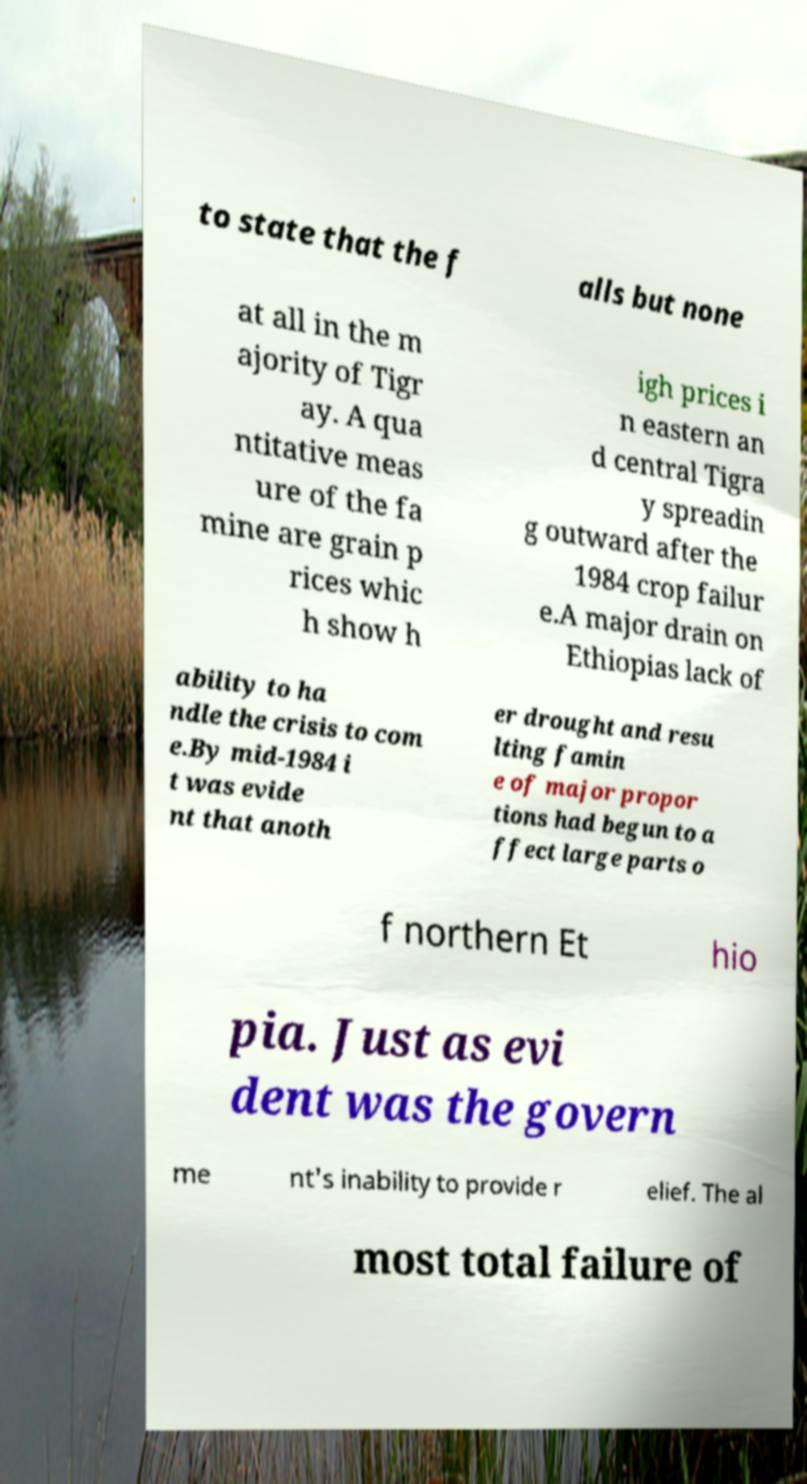Can you accurately transcribe the text from the provided image for me? to state that the f alls but none at all in the m ajority of Tigr ay. A qua ntitative meas ure of the fa mine are grain p rices whic h show h igh prices i n eastern an d central Tigra y spreadin g outward after the 1984 crop failur e.A major drain on Ethiopias lack of ability to ha ndle the crisis to com e.By mid-1984 i t was evide nt that anoth er drought and resu lting famin e of major propor tions had begun to a ffect large parts o f northern Et hio pia. Just as evi dent was the govern me nt's inability to provide r elief. The al most total failure of 